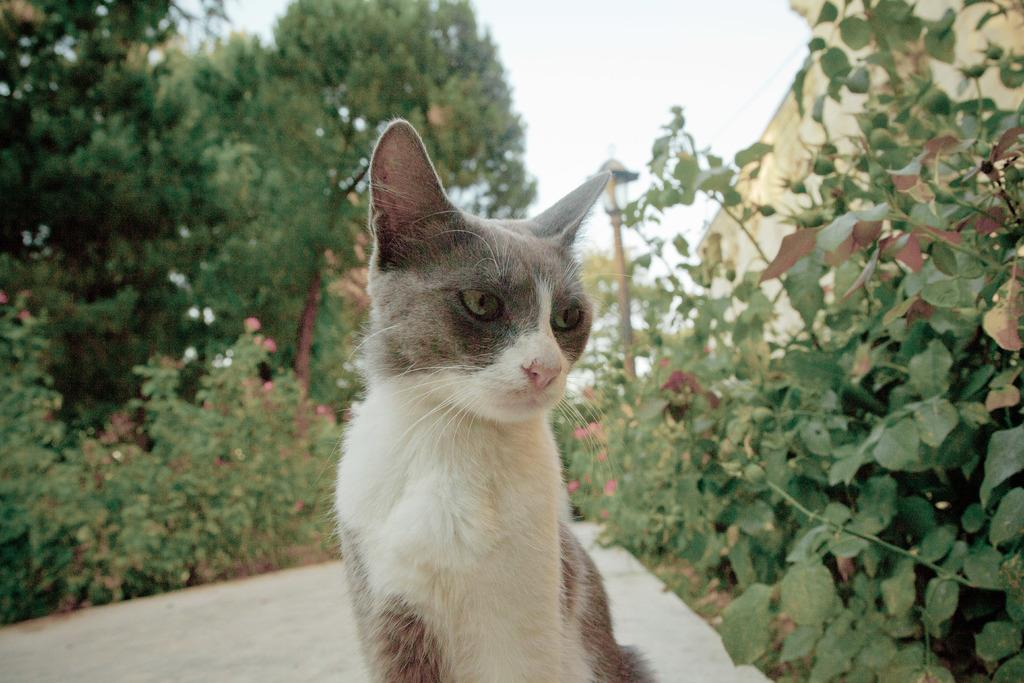What is the main subject in the middle of the image? There is a cat in the middle of the image. What can be seen in the background of the image? There are trees, plants, and flowers in the background of the image. Can you describe the lighting in the image? There is a light in the image. What type of structure is present in the image? There is a wall in the image. What type of bird is flying with a blade in the image? There is no bird or blade present in the image; it features a cat and various background elements. 